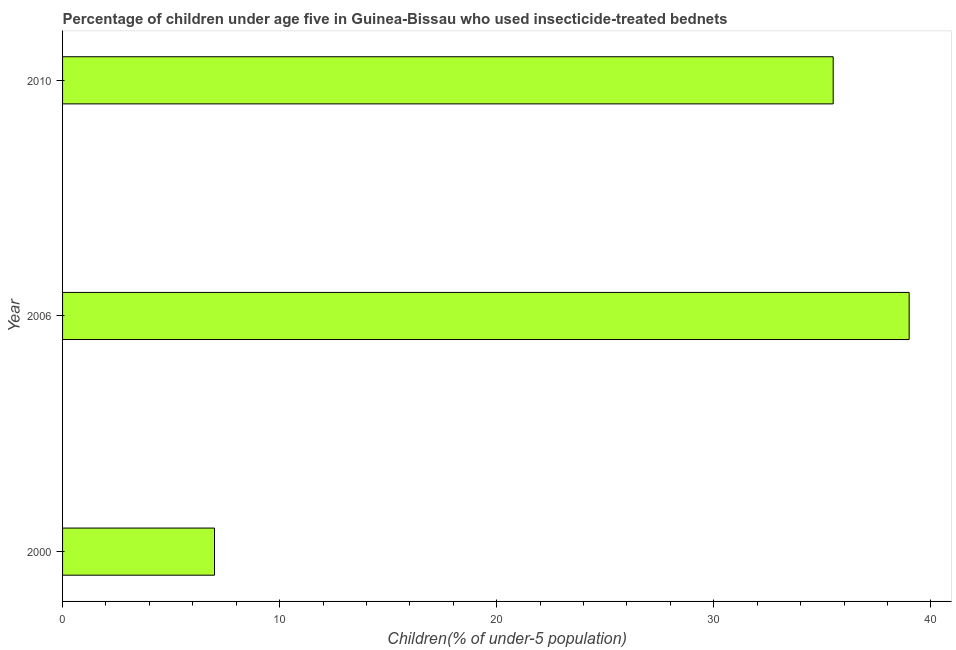What is the title of the graph?
Offer a very short reply. Percentage of children under age five in Guinea-Bissau who used insecticide-treated bednets. What is the label or title of the X-axis?
Provide a short and direct response. Children(% of under-5 population). What is the label or title of the Y-axis?
Your answer should be compact. Year. What is the sum of the percentage of children who use of insecticide-treated bed nets?
Provide a short and direct response. 81.5. What is the difference between the percentage of children who use of insecticide-treated bed nets in 2000 and 2010?
Your response must be concise. -28.5. What is the average percentage of children who use of insecticide-treated bed nets per year?
Make the answer very short. 27.17. What is the median percentage of children who use of insecticide-treated bed nets?
Give a very brief answer. 35.5. Do a majority of the years between 2006 and 2010 (inclusive) have percentage of children who use of insecticide-treated bed nets greater than 12 %?
Your answer should be compact. Yes. What is the ratio of the percentage of children who use of insecticide-treated bed nets in 2006 to that in 2010?
Keep it short and to the point. 1.1. Is the percentage of children who use of insecticide-treated bed nets in 2000 less than that in 2006?
Your response must be concise. Yes. Is the difference between the percentage of children who use of insecticide-treated bed nets in 2000 and 2006 greater than the difference between any two years?
Offer a terse response. Yes. What is the difference between the highest and the second highest percentage of children who use of insecticide-treated bed nets?
Your response must be concise. 3.5. Is the sum of the percentage of children who use of insecticide-treated bed nets in 2000 and 2010 greater than the maximum percentage of children who use of insecticide-treated bed nets across all years?
Keep it short and to the point. Yes. What is the Children(% of under-5 population) of 2000?
Your response must be concise. 7. What is the Children(% of under-5 population) in 2006?
Your answer should be very brief. 39. What is the Children(% of under-5 population) in 2010?
Make the answer very short. 35.5. What is the difference between the Children(% of under-5 population) in 2000 and 2006?
Make the answer very short. -32. What is the difference between the Children(% of under-5 population) in 2000 and 2010?
Provide a succinct answer. -28.5. What is the ratio of the Children(% of under-5 population) in 2000 to that in 2006?
Make the answer very short. 0.18. What is the ratio of the Children(% of under-5 population) in 2000 to that in 2010?
Your answer should be very brief. 0.2. What is the ratio of the Children(% of under-5 population) in 2006 to that in 2010?
Keep it short and to the point. 1.1. 